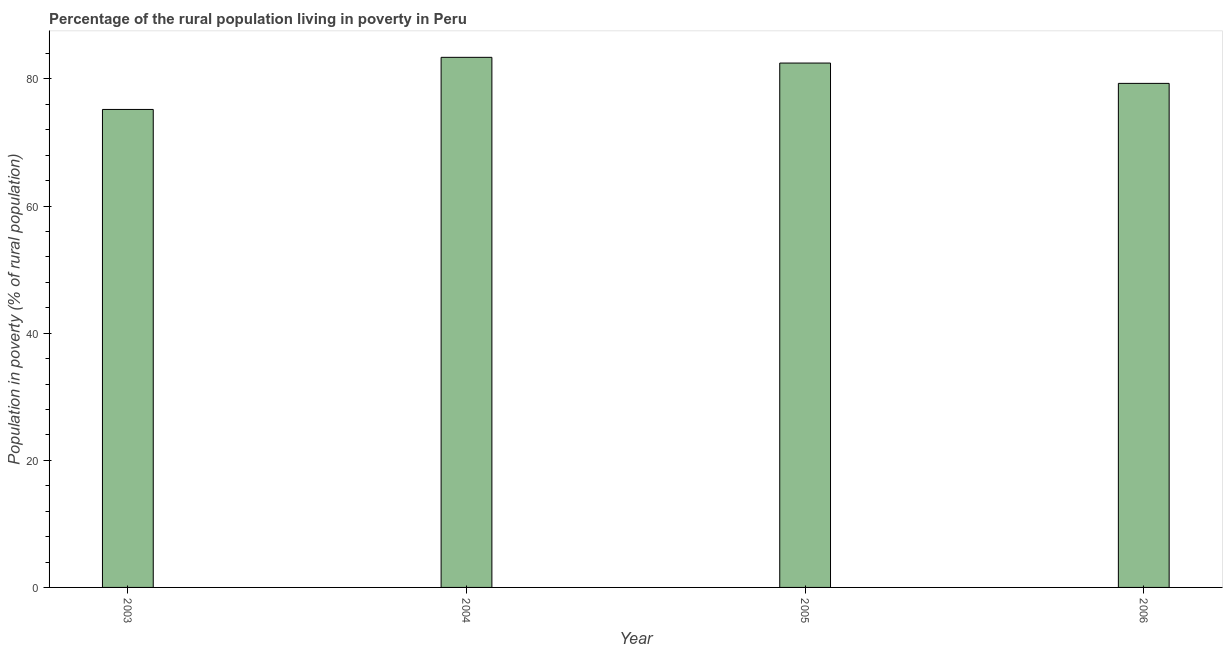Does the graph contain any zero values?
Ensure brevity in your answer.  No. Does the graph contain grids?
Give a very brief answer. No. What is the title of the graph?
Provide a succinct answer. Percentage of the rural population living in poverty in Peru. What is the label or title of the X-axis?
Provide a short and direct response. Year. What is the label or title of the Y-axis?
Keep it short and to the point. Population in poverty (% of rural population). What is the percentage of rural population living below poverty line in 2004?
Offer a terse response. 83.4. Across all years, what is the maximum percentage of rural population living below poverty line?
Offer a terse response. 83.4. Across all years, what is the minimum percentage of rural population living below poverty line?
Your answer should be compact. 75.2. In which year was the percentage of rural population living below poverty line minimum?
Make the answer very short. 2003. What is the sum of the percentage of rural population living below poverty line?
Ensure brevity in your answer.  320.4. What is the average percentage of rural population living below poverty line per year?
Your answer should be compact. 80.1. What is the median percentage of rural population living below poverty line?
Your answer should be very brief. 80.9. Do a majority of the years between 2003 and 2006 (inclusive) have percentage of rural population living below poverty line greater than 64 %?
Offer a terse response. Yes. What is the ratio of the percentage of rural population living below poverty line in 2003 to that in 2006?
Provide a short and direct response. 0.95. What is the difference between the highest and the second highest percentage of rural population living below poverty line?
Offer a terse response. 0.9. Is the sum of the percentage of rural population living below poverty line in 2004 and 2006 greater than the maximum percentage of rural population living below poverty line across all years?
Your answer should be very brief. Yes. What is the difference between the highest and the lowest percentage of rural population living below poverty line?
Ensure brevity in your answer.  8.2. In how many years, is the percentage of rural population living below poverty line greater than the average percentage of rural population living below poverty line taken over all years?
Offer a terse response. 2. Are all the bars in the graph horizontal?
Ensure brevity in your answer.  No. What is the Population in poverty (% of rural population) in 2003?
Make the answer very short. 75.2. What is the Population in poverty (% of rural population) of 2004?
Your response must be concise. 83.4. What is the Population in poverty (% of rural population) of 2005?
Make the answer very short. 82.5. What is the Population in poverty (% of rural population) in 2006?
Make the answer very short. 79.3. What is the difference between the Population in poverty (% of rural population) in 2003 and 2005?
Your response must be concise. -7.3. What is the difference between the Population in poverty (% of rural population) in 2003 and 2006?
Your response must be concise. -4.1. What is the difference between the Population in poverty (% of rural population) in 2005 and 2006?
Give a very brief answer. 3.2. What is the ratio of the Population in poverty (% of rural population) in 2003 to that in 2004?
Offer a very short reply. 0.9. What is the ratio of the Population in poverty (% of rural population) in 2003 to that in 2005?
Your response must be concise. 0.91. What is the ratio of the Population in poverty (% of rural population) in 2003 to that in 2006?
Keep it short and to the point. 0.95. What is the ratio of the Population in poverty (% of rural population) in 2004 to that in 2006?
Provide a short and direct response. 1.05. 